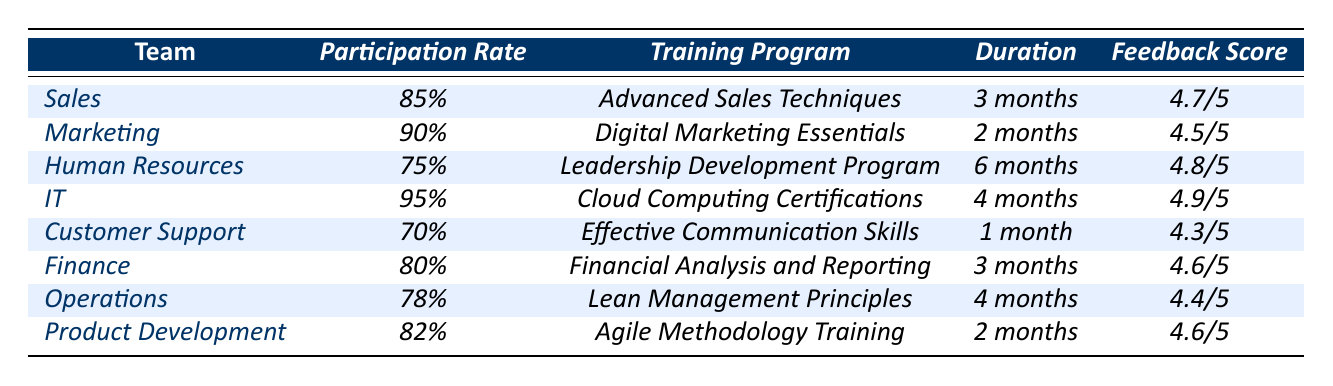What is the participation rate of the IT team in training and development? The table shows that the participation rate for the IT team is 95%.
Answer: 95% Which team received the highest feedback score? According to the table, the IT team received the highest feedback score of 4.9/5.
Answer: IT team What is the average participation rate across all teams? To find the average, sum the participation rates (85 + 90 + 75 + 95 + 70 + 80 + 78 + 82) = 675, then divide by the number of teams (8), which results in 675/8 = 84.375%.
Answer: 84.375% Is the participation rate of the Customer Support team higher than that of the Finance team? The table indicates that Customer Support has a participation rate of 70% while Finance has 80%. Therefore, no, it is not higher.
Answer: No What is the duration of the Leadership Development Program? The table lists the duration for the Leadership Development Program under Human Resources as 6 months.
Answer: 6 months What percentage of teams have a participation rate of 80% or higher? The teams with participation rates of 80% or higher are Sales (85%), Marketing (90%), IT (95%), and Finance (80%). That counts as 4 teams out of 8, which gives (4/8) * 100% = 50%.
Answer: 50% If we compare the feedback scores, is the IT team's score higher than the average feedback score? Calculate the average feedback score: (4.7 + 4.5 + 4.8 + 4.9 + 4.3 + 4.6 + 4.4 + 4.6) / 8 = 4.575. The IT team's score is 4.9, which is greater than 4.575.
Answer: Yes How many teams participated in training programs for 4 months? The table indicates that two teams, IT and Operations, participated in training programs lasting 4 months.
Answer: 2 teams Which training program had the lowest participation rate? The table shows that the Customer Support team had the lowest participation rate at 70%.
Answer: Effective Communication Skills What is the difference between the highest and lowest feedback scores? The highest feedback score is 4.9 from the IT team, and the lowest is 4.3 from Customer Support. The difference is 4.9 - 4.3 = 0.6.
Answer: 0.6 